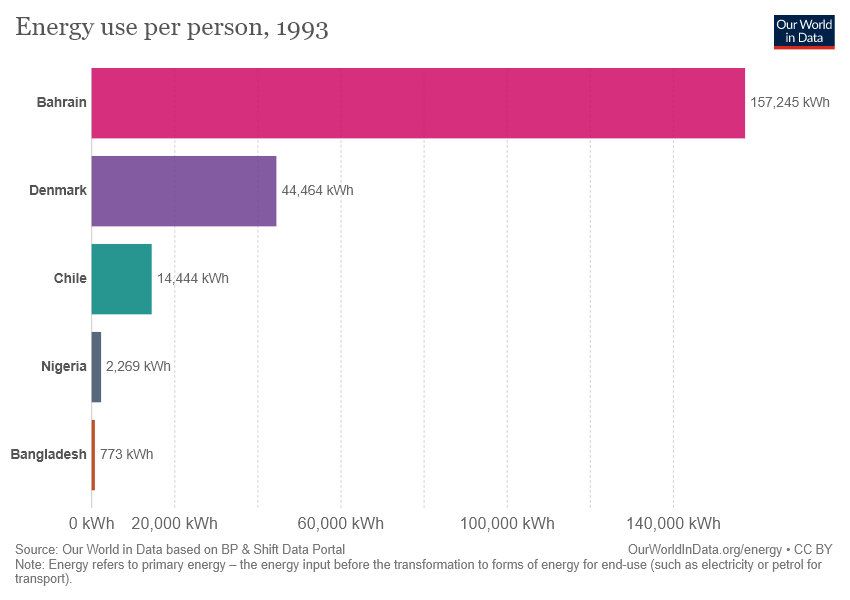Point out several critical features in this image. The sum of the four lowest values is less than the highest value in the given scenario. Bahrain is the place that consumes the most energy. 